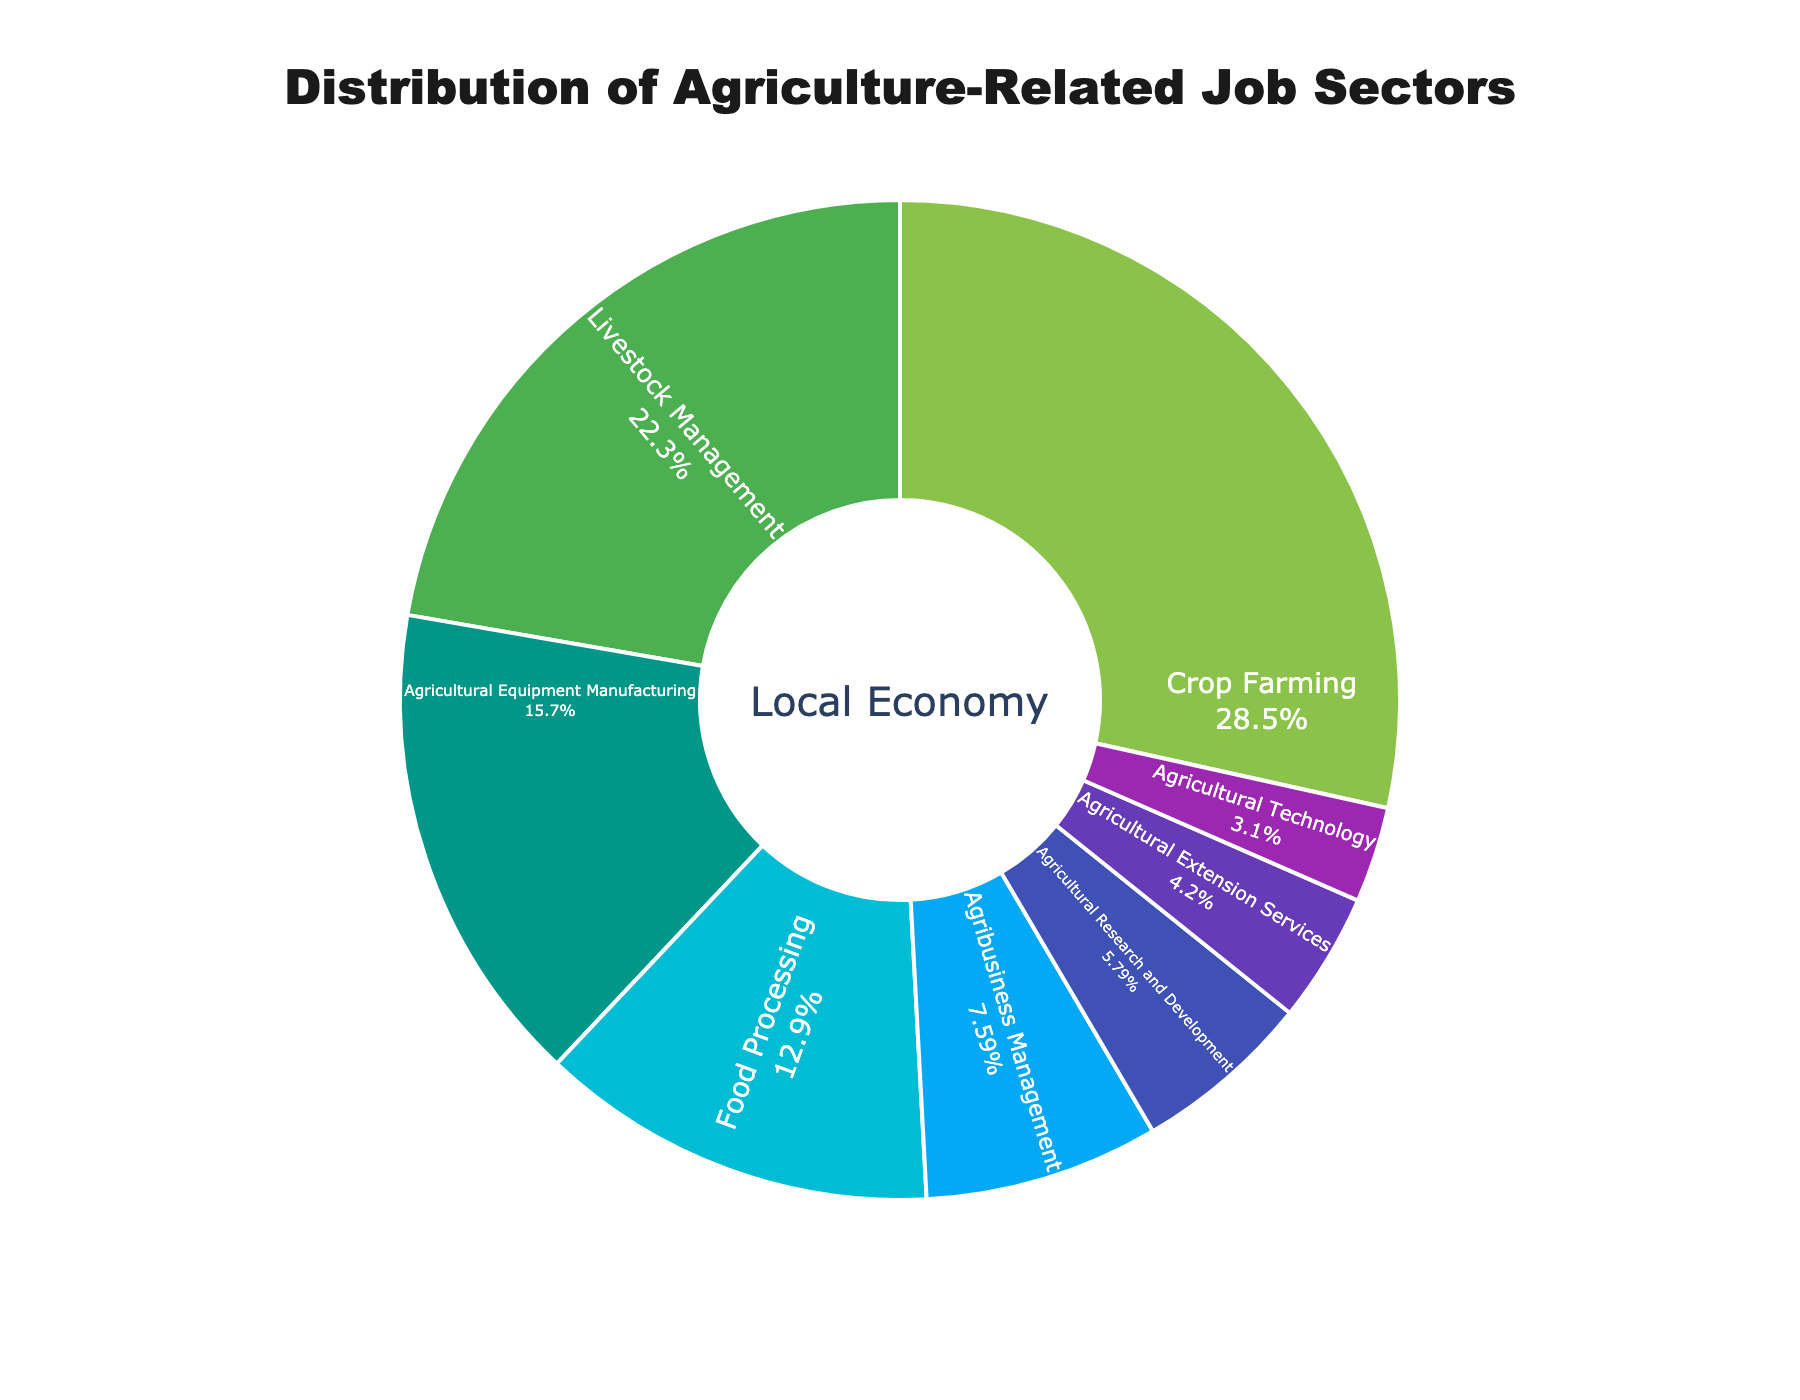What is the largest sector in the distribution of agriculture-related job sectors? To find the largest sector, look for the segment with the highest percentage in the pie chart. "Crop Farming" has the highest value at 28.5%.
Answer: Crop Farming Which sector has the second smallest percentage of job distribution? To identify the second smallest sector, first find the smallest percentage, which is "Agricultural Technology" at 3.1%, then find the next smallest, which is "Agricultural Extension Services" at 4.2%.
Answer: Agricultural Extension Services How much larger is the percentage of Crop Farming compared to Food Processing? Crop Farming is 28.5% and Food Processing is 12.9%. Subtract the two to find the difference: 28.5% - 12.9% = 15.6%.
Answer: 15.6% What is the combined total percentage of Agricultural Equipment Manufacturing, Food Processing, and Agricultural Technology? Add the percentages of the specified sectors: 15.7% (Agricultural Equipment Manufacturing) + 12.9% (Food Processing) + 3.1% (Agricultural Technology), resulting in a total of 31.7%.
Answer: 31.7% Which sector has a higher percentage: Agricultural Research and Development or Agribusiness Management? Compare the two percentages: Agribusiness Management (7.6%) and Agricultural Research and Development (5.8%). Agribusiness Management has a higher percentage.
Answer: Agribusiness Management What sector follows Livestock Management in terms of job sector distribution by percentage? Look for the sector with the next highest percentage after Livestock Management (22.3%). The following sector is Agricultural Equipment Manufacturing at 15.7%.
Answer: Agricultural Equipment Manufacturing By how much does the percentage of Livestock Management exceed that of Agricultural Research and Development? Subtract the percentage of Agricultural Research and Development (5.8%) from Livestock Management (22.3%): 22.3% - 5.8% = 16.5%.
Answer: 16.5% Sum the percentages of the three smallest sectors. Add the percentages of the three smallest sectors: Agricultural Technology (3.1%), Agricultural Extension Services (4.2%), and Agricultural Research and Development (5.8%). 3.1% + 4.2% + 5.8% = 13.1%.
Answer: 13.1% What visual element highlights the center of the pie chart? The center of the pie chart features the text "Local Economy" written prominently.
Answer: Local Economy 